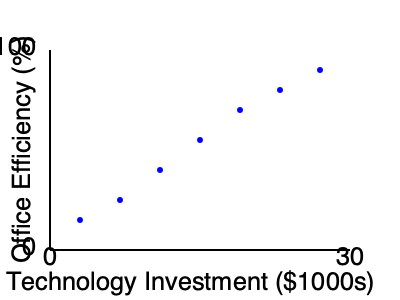Based on the scatter plot showing the relationship between technology investment and office efficiency, what can be concluded about the overall trend? To determine the overall trend in the scatter plot, we need to analyze the relationship between the two variables:

1. Observe the x-axis (Technology Investment) and y-axis (Office Efficiency).
2. Notice that as we move from left to right (increasing technology investment):
   a. The points generally move upwards (increasing office efficiency).
   b. This indicates a positive correlation between the two variables.
3. The relationship appears to be roughly linear, as the points form a generally straight line pattern.
4. There are no significant outliers or deviations from the overall trend.
5. The slope of the trend is positive, indicating that as technology investment increases, office efficiency tends to increase as well.
6. The relationship seems strong, as the points are clustered relatively close to an imaginary line of best fit.

Given these observations, we can conclude that there is a strong positive correlation between technology investment and office efficiency.
Answer: Strong positive correlation 